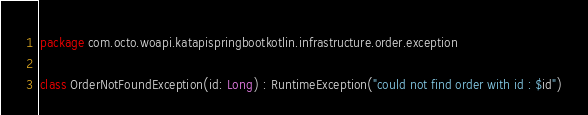Convert code to text. <code><loc_0><loc_0><loc_500><loc_500><_Kotlin_>package com.octo.woapi.katapispringbootkotlin.infrastructure.order.exception

class OrderNotFoundException(id: Long) : RuntimeException("could not find order with id : $id")</code> 